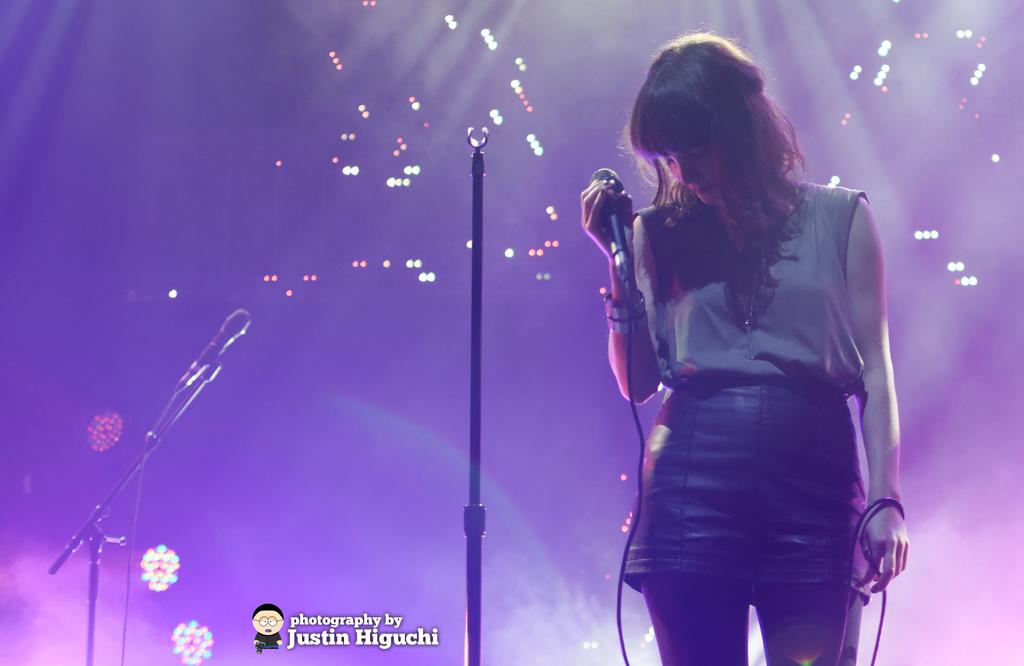Who is the main subject in the image? There is a woman in the image. What is the woman wearing? The woman is wearing a grey shirt and a black skirt. What is the woman doing in the image? The woman is standing and holding a microphone in her hand. What else can be seen in the background of the image? There is a microphone and lights in the background of the image. How many beginner snakes are visible on the woman's side in the image? There are no snakes present in the image, and the woman's side is not mentioned in the provided facts. 